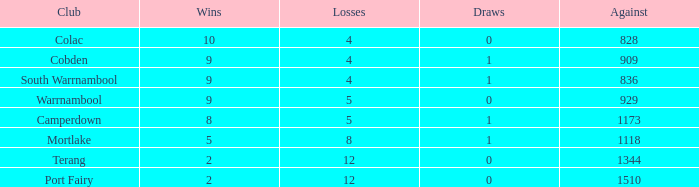For "against" values over 1510, what is the combined loss amount? None. 